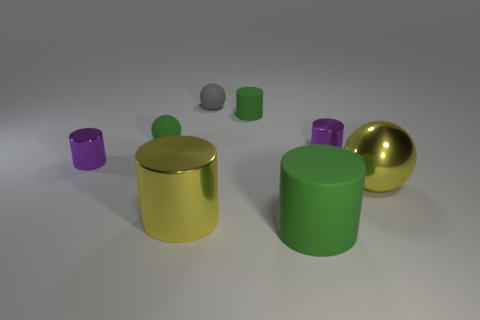There is a large object that is the same color as the large shiny cylinder; what is it made of?
Offer a terse response. Metal. What size is the cylinder that is the same color as the big sphere?
Offer a terse response. Large. Are there any rubber blocks that have the same size as the yellow sphere?
Offer a terse response. No. There is a small gray thing; is it the same shape as the purple object left of the yellow cylinder?
Your answer should be very brief. No. Is the size of the cylinder that is behind the green sphere the same as the rubber ball that is right of the large yellow cylinder?
Offer a very short reply. Yes. What number of other objects are the same shape as the gray thing?
Ensure brevity in your answer.  2. There is a small purple thing that is behind the small purple thing that is left of the tiny green ball; what is its material?
Provide a short and direct response. Metal. How many rubber things are large green things or small gray spheres?
Ensure brevity in your answer.  2. Is there any other thing that has the same material as the small green ball?
Keep it short and to the point. Yes. Are there any metal balls behind the tiny metallic cylinder right of the gray matte object?
Your response must be concise. No. 